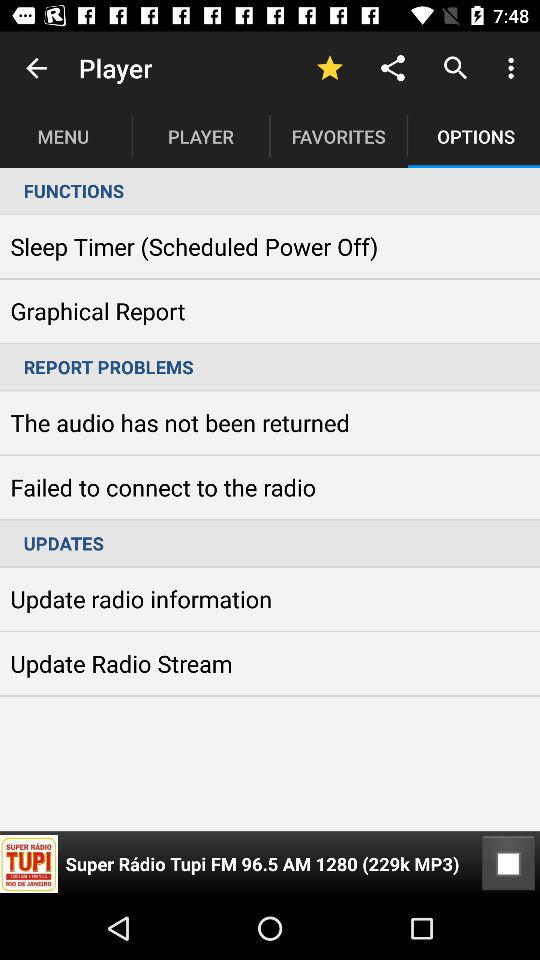Which option is selected in the "Player"? The selected option is "OPTIONS". 